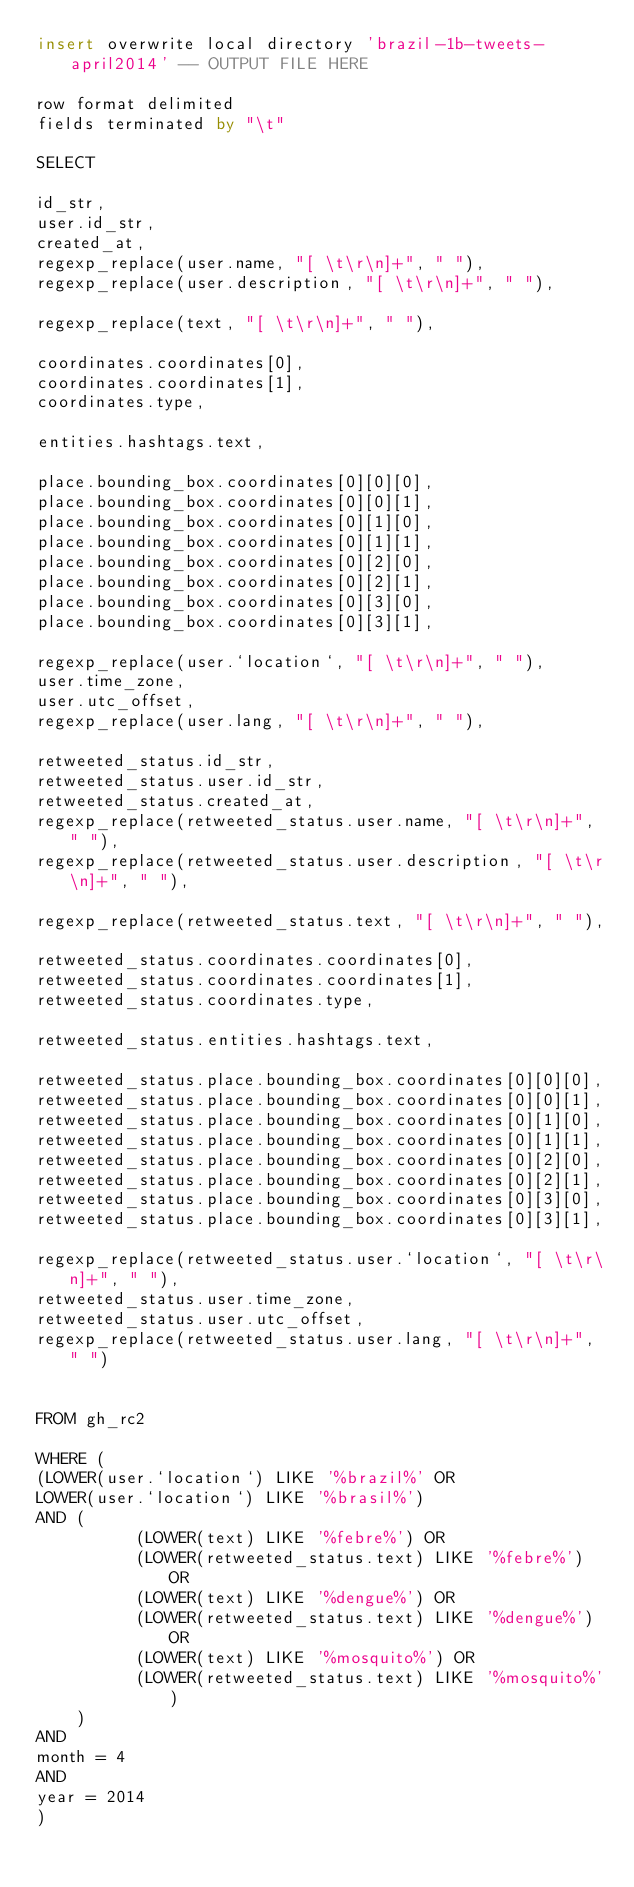Convert code to text. <code><loc_0><loc_0><loc_500><loc_500><_SQL_>insert overwrite local directory 'brazil-1b-tweets-april2014' -- OUTPUT FILE HERE

row format delimited
fields terminated by "\t"

SELECT

id_str,
user.id_str,
created_at,
regexp_replace(user.name, "[ \t\r\n]+", " "),
regexp_replace(user.description, "[ \t\r\n]+", " "),

regexp_replace(text, "[ \t\r\n]+", " "),

coordinates.coordinates[0],
coordinates.coordinates[1],
coordinates.type,

entities.hashtags.text,

place.bounding_box.coordinates[0][0][0],
place.bounding_box.coordinates[0][0][1],
place.bounding_box.coordinates[0][1][0],
place.bounding_box.coordinates[0][1][1],
place.bounding_box.coordinates[0][2][0],
place.bounding_box.coordinates[0][2][1],
place.bounding_box.coordinates[0][3][0],
place.bounding_box.coordinates[0][3][1],

regexp_replace(user.`location`, "[ \t\r\n]+", " "),
user.time_zone,
user.utc_offset,
regexp_replace(user.lang, "[ \t\r\n]+", " "),

retweeted_status.id_str,
retweeted_status.user.id_str,
retweeted_status.created_at,
regexp_replace(retweeted_status.user.name, "[ \t\r\n]+", " "),
regexp_replace(retweeted_status.user.description, "[ \t\r\n]+", " "),

regexp_replace(retweeted_status.text, "[ \t\r\n]+", " "),

retweeted_status.coordinates.coordinates[0],
retweeted_status.coordinates.coordinates[1],
retweeted_status.coordinates.type,

retweeted_status.entities.hashtags.text,

retweeted_status.place.bounding_box.coordinates[0][0][0],
retweeted_status.place.bounding_box.coordinates[0][0][1],
retweeted_status.place.bounding_box.coordinates[0][1][0],
retweeted_status.place.bounding_box.coordinates[0][1][1],
retweeted_status.place.bounding_box.coordinates[0][2][0],
retweeted_status.place.bounding_box.coordinates[0][2][1],
retweeted_status.place.bounding_box.coordinates[0][3][0],
retweeted_status.place.bounding_box.coordinates[0][3][1],

regexp_replace(retweeted_status.user.`location`, "[ \t\r\n]+", " "),
retweeted_status.user.time_zone,
retweeted_status.user.utc_offset,
regexp_replace(retweeted_status.user.lang, "[ \t\r\n]+", " ")


FROM gh_rc2

WHERE (
(LOWER(user.`location`) LIKE '%brazil%' OR 
LOWER(user.`location`) LIKE '%brasil%')
AND (
        	(LOWER(text) LIKE '%febre%') OR
	        (LOWER(retweeted_status.text) LIKE '%febre%') OR
        	(LOWER(text) LIKE '%dengue%') OR
	        (LOWER(retweeted_status.text) LIKE '%dengue%') OR
        	(LOWER(text) LIKE '%mosquito%') OR
	        (LOWER(retweeted_status.text) LIKE '%mosquito%') 
		)
AND 
month = 4
AND
year = 2014
)
</code> 